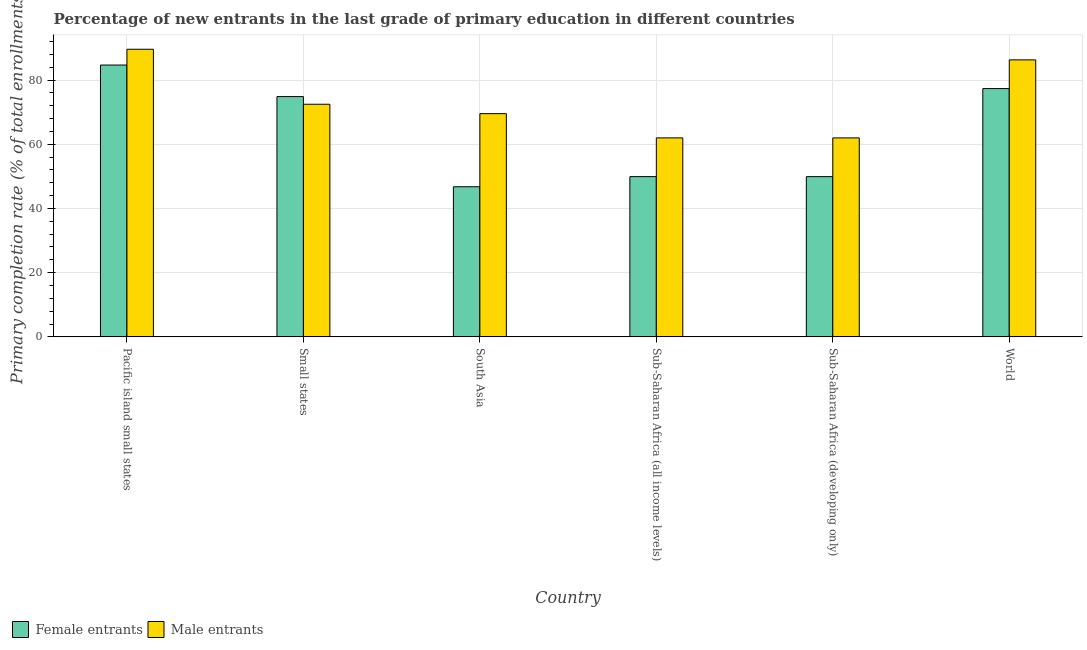How many different coloured bars are there?
Keep it short and to the point. 2. Are the number of bars per tick equal to the number of legend labels?
Provide a succinct answer. Yes. Are the number of bars on each tick of the X-axis equal?
Your response must be concise. Yes. How many bars are there on the 4th tick from the right?
Give a very brief answer. 2. What is the label of the 1st group of bars from the left?
Keep it short and to the point. Pacific island small states. In how many cases, is the number of bars for a given country not equal to the number of legend labels?
Keep it short and to the point. 0. What is the primary completion rate of male entrants in Small states?
Provide a short and direct response. 72.45. Across all countries, what is the maximum primary completion rate of male entrants?
Give a very brief answer. 89.58. Across all countries, what is the minimum primary completion rate of male entrants?
Provide a short and direct response. 61.97. In which country was the primary completion rate of male entrants maximum?
Offer a very short reply. Pacific island small states. What is the total primary completion rate of female entrants in the graph?
Your answer should be compact. 383.44. What is the difference between the primary completion rate of female entrants in South Asia and that in World?
Offer a very short reply. -30.58. What is the difference between the primary completion rate of female entrants in Small states and the primary completion rate of male entrants in Sub-Saharan Africa (all income levels)?
Provide a succinct answer. 12.87. What is the average primary completion rate of female entrants per country?
Your response must be concise. 63.91. What is the difference between the primary completion rate of male entrants and primary completion rate of female entrants in South Asia?
Offer a very short reply. 22.77. What is the ratio of the primary completion rate of female entrants in Pacific island small states to that in World?
Provide a succinct answer. 1.09. Is the primary completion rate of female entrants in Sub-Saharan Africa (developing only) less than that in World?
Keep it short and to the point. Yes. Is the difference between the primary completion rate of female entrants in Sub-Saharan Africa (developing only) and World greater than the difference between the primary completion rate of male entrants in Sub-Saharan Africa (developing only) and World?
Ensure brevity in your answer.  No. What is the difference between the highest and the second highest primary completion rate of female entrants?
Provide a short and direct response. 7.33. What is the difference between the highest and the lowest primary completion rate of female entrants?
Your answer should be very brief. 37.91. Is the sum of the primary completion rate of female entrants in Pacific island small states and South Asia greater than the maximum primary completion rate of male entrants across all countries?
Your response must be concise. Yes. What does the 1st bar from the left in South Asia represents?
Your answer should be very brief. Female entrants. What does the 1st bar from the right in World represents?
Ensure brevity in your answer.  Male entrants. Does the graph contain any zero values?
Your answer should be compact. No. Where does the legend appear in the graph?
Your response must be concise. Bottom left. How many legend labels are there?
Give a very brief answer. 2. How are the legend labels stacked?
Ensure brevity in your answer.  Horizontal. What is the title of the graph?
Provide a short and direct response. Percentage of new entrants in the last grade of primary education in different countries. Does "Diarrhea" appear as one of the legend labels in the graph?
Provide a short and direct response. No. What is the label or title of the Y-axis?
Your answer should be compact. Primary completion rate (% of total enrollments). What is the Primary completion rate (% of total enrollments) of Female entrants in Pacific island small states?
Your answer should be very brief. 84.67. What is the Primary completion rate (% of total enrollments) in Male entrants in Pacific island small states?
Offer a very short reply. 89.58. What is the Primary completion rate (% of total enrollments) in Female entrants in Small states?
Offer a very short reply. 74.85. What is the Primary completion rate (% of total enrollments) of Male entrants in Small states?
Provide a succinct answer. 72.45. What is the Primary completion rate (% of total enrollments) of Female entrants in South Asia?
Your answer should be compact. 46.76. What is the Primary completion rate (% of total enrollments) of Male entrants in South Asia?
Provide a short and direct response. 69.53. What is the Primary completion rate (% of total enrollments) of Female entrants in Sub-Saharan Africa (all income levels)?
Give a very brief answer. 49.92. What is the Primary completion rate (% of total enrollments) of Male entrants in Sub-Saharan Africa (all income levels)?
Your response must be concise. 61.98. What is the Primary completion rate (% of total enrollments) of Female entrants in Sub-Saharan Africa (developing only)?
Provide a short and direct response. 49.91. What is the Primary completion rate (% of total enrollments) of Male entrants in Sub-Saharan Africa (developing only)?
Give a very brief answer. 61.97. What is the Primary completion rate (% of total enrollments) in Female entrants in World?
Provide a short and direct response. 77.34. What is the Primary completion rate (% of total enrollments) of Male entrants in World?
Keep it short and to the point. 86.28. Across all countries, what is the maximum Primary completion rate (% of total enrollments) in Female entrants?
Your answer should be very brief. 84.67. Across all countries, what is the maximum Primary completion rate (% of total enrollments) in Male entrants?
Your answer should be compact. 89.58. Across all countries, what is the minimum Primary completion rate (% of total enrollments) in Female entrants?
Give a very brief answer. 46.76. Across all countries, what is the minimum Primary completion rate (% of total enrollments) of Male entrants?
Provide a short and direct response. 61.97. What is the total Primary completion rate (% of total enrollments) in Female entrants in the graph?
Make the answer very short. 383.44. What is the total Primary completion rate (% of total enrollments) in Male entrants in the graph?
Ensure brevity in your answer.  441.79. What is the difference between the Primary completion rate (% of total enrollments) in Female entrants in Pacific island small states and that in Small states?
Offer a very short reply. 9.82. What is the difference between the Primary completion rate (% of total enrollments) in Male entrants in Pacific island small states and that in Small states?
Offer a very short reply. 17.13. What is the difference between the Primary completion rate (% of total enrollments) of Female entrants in Pacific island small states and that in South Asia?
Offer a terse response. 37.91. What is the difference between the Primary completion rate (% of total enrollments) in Male entrants in Pacific island small states and that in South Asia?
Offer a very short reply. 20.06. What is the difference between the Primary completion rate (% of total enrollments) in Female entrants in Pacific island small states and that in Sub-Saharan Africa (all income levels)?
Give a very brief answer. 34.75. What is the difference between the Primary completion rate (% of total enrollments) of Male entrants in Pacific island small states and that in Sub-Saharan Africa (all income levels)?
Provide a short and direct response. 27.61. What is the difference between the Primary completion rate (% of total enrollments) of Female entrants in Pacific island small states and that in Sub-Saharan Africa (developing only)?
Your response must be concise. 34.76. What is the difference between the Primary completion rate (% of total enrollments) of Male entrants in Pacific island small states and that in Sub-Saharan Africa (developing only)?
Your answer should be very brief. 27.61. What is the difference between the Primary completion rate (% of total enrollments) in Female entrants in Pacific island small states and that in World?
Your response must be concise. 7.33. What is the difference between the Primary completion rate (% of total enrollments) in Male entrants in Pacific island small states and that in World?
Offer a terse response. 3.31. What is the difference between the Primary completion rate (% of total enrollments) in Female entrants in Small states and that in South Asia?
Offer a very short reply. 28.09. What is the difference between the Primary completion rate (% of total enrollments) of Male entrants in Small states and that in South Asia?
Make the answer very short. 2.93. What is the difference between the Primary completion rate (% of total enrollments) in Female entrants in Small states and that in Sub-Saharan Africa (all income levels)?
Offer a very short reply. 24.93. What is the difference between the Primary completion rate (% of total enrollments) of Male entrants in Small states and that in Sub-Saharan Africa (all income levels)?
Offer a terse response. 10.47. What is the difference between the Primary completion rate (% of total enrollments) in Female entrants in Small states and that in Sub-Saharan Africa (developing only)?
Offer a very short reply. 24.94. What is the difference between the Primary completion rate (% of total enrollments) in Male entrants in Small states and that in Sub-Saharan Africa (developing only)?
Provide a short and direct response. 10.48. What is the difference between the Primary completion rate (% of total enrollments) of Female entrants in Small states and that in World?
Make the answer very short. -2.49. What is the difference between the Primary completion rate (% of total enrollments) in Male entrants in Small states and that in World?
Provide a succinct answer. -13.83. What is the difference between the Primary completion rate (% of total enrollments) in Female entrants in South Asia and that in Sub-Saharan Africa (all income levels)?
Make the answer very short. -3.16. What is the difference between the Primary completion rate (% of total enrollments) in Male entrants in South Asia and that in Sub-Saharan Africa (all income levels)?
Give a very brief answer. 7.55. What is the difference between the Primary completion rate (% of total enrollments) of Female entrants in South Asia and that in Sub-Saharan Africa (developing only)?
Your answer should be compact. -3.15. What is the difference between the Primary completion rate (% of total enrollments) in Male entrants in South Asia and that in Sub-Saharan Africa (developing only)?
Offer a terse response. 7.55. What is the difference between the Primary completion rate (% of total enrollments) of Female entrants in South Asia and that in World?
Offer a terse response. -30.58. What is the difference between the Primary completion rate (% of total enrollments) of Male entrants in South Asia and that in World?
Offer a very short reply. -16.75. What is the difference between the Primary completion rate (% of total enrollments) of Female entrants in Sub-Saharan Africa (all income levels) and that in Sub-Saharan Africa (developing only)?
Your response must be concise. 0.01. What is the difference between the Primary completion rate (% of total enrollments) in Male entrants in Sub-Saharan Africa (all income levels) and that in Sub-Saharan Africa (developing only)?
Offer a very short reply. 0. What is the difference between the Primary completion rate (% of total enrollments) of Female entrants in Sub-Saharan Africa (all income levels) and that in World?
Provide a short and direct response. -27.42. What is the difference between the Primary completion rate (% of total enrollments) in Male entrants in Sub-Saharan Africa (all income levels) and that in World?
Make the answer very short. -24.3. What is the difference between the Primary completion rate (% of total enrollments) of Female entrants in Sub-Saharan Africa (developing only) and that in World?
Provide a short and direct response. -27.43. What is the difference between the Primary completion rate (% of total enrollments) in Male entrants in Sub-Saharan Africa (developing only) and that in World?
Offer a terse response. -24.3. What is the difference between the Primary completion rate (% of total enrollments) of Female entrants in Pacific island small states and the Primary completion rate (% of total enrollments) of Male entrants in Small states?
Give a very brief answer. 12.22. What is the difference between the Primary completion rate (% of total enrollments) in Female entrants in Pacific island small states and the Primary completion rate (% of total enrollments) in Male entrants in South Asia?
Keep it short and to the point. 15.14. What is the difference between the Primary completion rate (% of total enrollments) in Female entrants in Pacific island small states and the Primary completion rate (% of total enrollments) in Male entrants in Sub-Saharan Africa (all income levels)?
Your answer should be very brief. 22.69. What is the difference between the Primary completion rate (% of total enrollments) in Female entrants in Pacific island small states and the Primary completion rate (% of total enrollments) in Male entrants in Sub-Saharan Africa (developing only)?
Provide a short and direct response. 22.7. What is the difference between the Primary completion rate (% of total enrollments) of Female entrants in Pacific island small states and the Primary completion rate (% of total enrollments) of Male entrants in World?
Make the answer very short. -1.61. What is the difference between the Primary completion rate (% of total enrollments) of Female entrants in Small states and the Primary completion rate (% of total enrollments) of Male entrants in South Asia?
Ensure brevity in your answer.  5.32. What is the difference between the Primary completion rate (% of total enrollments) of Female entrants in Small states and the Primary completion rate (% of total enrollments) of Male entrants in Sub-Saharan Africa (all income levels)?
Give a very brief answer. 12.87. What is the difference between the Primary completion rate (% of total enrollments) of Female entrants in Small states and the Primary completion rate (% of total enrollments) of Male entrants in Sub-Saharan Africa (developing only)?
Make the answer very short. 12.87. What is the difference between the Primary completion rate (% of total enrollments) of Female entrants in Small states and the Primary completion rate (% of total enrollments) of Male entrants in World?
Provide a short and direct response. -11.43. What is the difference between the Primary completion rate (% of total enrollments) in Female entrants in South Asia and the Primary completion rate (% of total enrollments) in Male entrants in Sub-Saharan Africa (all income levels)?
Give a very brief answer. -15.22. What is the difference between the Primary completion rate (% of total enrollments) in Female entrants in South Asia and the Primary completion rate (% of total enrollments) in Male entrants in Sub-Saharan Africa (developing only)?
Offer a terse response. -15.21. What is the difference between the Primary completion rate (% of total enrollments) in Female entrants in South Asia and the Primary completion rate (% of total enrollments) in Male entrants in World?
Offer a very short reply. -39.52. What is the difference between the Primary completion rate (% of total enrollments) of Female entrants in Sub-Saharan Africa (all income levels) and the Primary completion rate (% of total enrollments) of Male entrants in Sub-Saharan Africa (developing only)?
Provide a short and direct response. -12.06. What is the difference between the Primary completion rate (% of total enrollments) of Female entrants in Sub-Saharan Africa (all income levels) and the Primary completion rate (% of total enrollments) of Male entrants in World?
Your response must be concise. -36.36. What is the difference between the Primary completion rate (% of total enrollments) in Female entrants in Sub-Saharan Africa (developing only) and the Primary completion rate (% of total enrollments) in Male entrants in World?
Offer a very short reply. -36.37. What is the average Primary completion rate (% of total enrollments) of Female entrants per country?
Ensure brevity in your answer.  63.91. What is the average Primary completion rate (% of total enrollments) in Male entrants per country?
Your answer should be very brief. 73.63. What is the difference between the Primary completion rate (% of total enrollments) in Female entrants and Primary completion rate (% of total enrollments) in Male entrants in Pacific island small states?
Provide a succinct answer. -4.92. What is the difference between the Primary completion rate (% of total enrollments) in Female entrants and Primary completion rate (% of total enrollments) in Male entrants in Small states?
Your answer should be very brief. 2.4. What is the difference between the Primary completion rate (% of total enrollments) in Female entrants and Primary completion rate (% of total enrollments) in Male entrants in South Asia?
Provide a succinct answer. -22.77. What is the difference between the Primary completion rate (% of total enrollments) in Female entrants and Primary completion rate (% of total enrollments) in Male entrants in Sub-Saharan Africa (all income levels)?
Keep it short and to the point. -12.06. What is the difference between the Primary completion rate (% of total enrollments) in Female entrants and Primary completion rate (% of total enrollments) in Male entrants in Sub-Saharan Africa (developing only)?
Provide a succinct answer. -12.07. What is the difference between the Primary completion rate (% of total enrollments) in Female entrants and Primary completion rate (% of total enrollments) in Male entrants in World?
Make the answer very short. -8.94. What is the ratio of the Primary completion rate (% of total enrollments) in Female entrants in Pacific island small states to that in Small states?
Make the answer very short. 1.13. What is the ratio of the Primary completion rate (% of total enrollments) in Male entrants in Pacific island small states to that in Small states?
Your answer should be compact. 1.24. What is the ratio of the Primary completion rate (% of total enrollments) in Female entrants in Pacific island small states to that in South Asia?
Give a very brief answer. 1.81. What is the ratio of the Primary completion rate (% of total enrollments) of Male entrants in Pacific island small states to that in South Asia?
Your response must be concise. 1.29. What is the ratio of the Primary completion rate (% of total enrollments) in Female entrants in Pacific island small states to that in Sub-Saharan Africa (all income levels)?
Your answer should be very brief. 1.7. What is the ratio of the Primary completion rate (% of total enrollments) in Male entrants in Pacific island small states to that in Sub-Saharan Africa (all income levels)?
Your answer should be very brief. 1.45. What is the ratio of the Primary completion rate (% of total enrollments) in Female entrants in Pacific island small states to that in Sub-Saharan Africa (developing only)?
Your answer should be very brief. 1.7. What is the ratio of the Primary completion rate (% of total enrollments) of Male entrants in Pacific island small states to that in Sub-Saharan Africa (developing only)?
Your answer should be compact. 1.45. What is the ratio of the Primary completion rate (% of total enrollments) of Female entrants in Pacific island small states to that in World?
Offer a terse response. 1.09. What is the ratio of the Primary completion rate (% of total enrollments) of Male entrants in Pacific island small states to that in World?
Offer a terse response. 1.04. What is the ratio of the Primary completion rate (% of total enrollments) of Female entrants in Small states to that in South Asia?
Provide a succinct answer. 1.6. What is the ratio of the Primary completion rate (% of total enrollments) of Male entrants in Small states to that in South Asia?
Provide a short and direct response. 1.04. What is the ratio of the Primary completion rate (% of total enrollments) of Female entrants in Small states to that in Sub-Saharan Africa (all income levels)?
Offer a terse response. 1.5. What is the ratio of the Primary completion rate (% of total enrollments) in Male entrants in Small states to that in Sub-Saharan Africa (all income levels)?
Make the answer very short. 1.17. What is the ratio of the Primary completion rate (% of total enrollments) in Female entrants in Small states to that in Sub-Saharan Africa (developing only)?
Provide a short and direct response. 1.5. What is the ratio of the Primary completion rate (% of total enrollments) of Male entrants in Small states to that in Sub-Saharan Africa (developing only)?
Make the answer very short. 1.17. What is the ratio of the Primary completion rate (% of total enrollments) in Female entrants in Small states to that in World?
Offer a very short reply. 0.97. What is the ratio of the Primary completion rate (% of total enrollments) of Male entrants in Small states to that in World?
Give a very brief answer. 0.84. What is the ratio of the Primary completion rate (% of total enrollments) of Female entrants in South Asia to that in Sub-Saharan Africa (all income levels)?
Offer a very short reply. 0.94. What is the ratio of the Primary completion rate (% of total enrollments) in Male entrants in South Asia to that in Sub-Saharan Africa (all income levels)?
Offer a very short reply. 1.12. What is the ratio of the Primary completion rate (% of total enrollments) in Female entrants in South Asia to that in Sub-Saharan Africa (developing only)?
Your answer should be very brief. 0.94. What is the ratio of the Primary completion rate (% of total enrollments) in Male entrants in South Asia to that in Sub-Saharan Africa (developing only)?
Offer a terse response. 1.12. What is the ratio of the Primary completion rate (% of total enrollments) of Female entrants in South Asia to that in World?
Your answer should be very brief. 0.6. What is the ratio of the Primary completion rate (% of total enrollments) in Male entrants in South Asia to that in World?
Offer a terse response. 0.81. What is the ratio of the Primary completion rate (% of total enrollments) of Male entrants in Sub-Saharan Africa (all income levels) to that in Sub-Saharan Africa (developing only)?
Offer a very short reply. 1. What is the ratio of the Primary completion rate (% of total enrollments) in Female entrants in Sub-Saharan Africa (all income levels) to that in World?
Offer a very short reply. 0.65. What is the ratio of the Primary completion rate (% of total enrollments) of Male entrants in Sub-Saharan Africa (all income levels) to that in World?
Offer a very short reply. 0.72. What is the ratio of the Primary completion rate (% of total enrollments) of Female entrants in Sub-Saharan Africa (developing only) to that in World?
Offer a very short reply. 0.65. What is the ratio of the Primary completion rate (% of total enrollments) in Male entrants in Sub-Saharan Africa (developing only) to that in World?
Give a very brief answer. 0.72. What is the difference between the highest and the second highest Primary completion rate (% of total enrollments) of Female entrants?
Offer a terse response. 7.33. What is the difference between the highest and the second highest Primary completion rate (% of total enrollments) in Male entrants?
Make the answer very short. 3.31. What is the difference between the highest and the lowest Primary completion rate (% of total enrollments) of Female entrants?
Your answer should be very brief. 37.91. What is the difference between the highest and the lowest Primary completion rate (% of total enrollments) of Male entrants?
Offer a very short reply. 27.61. 